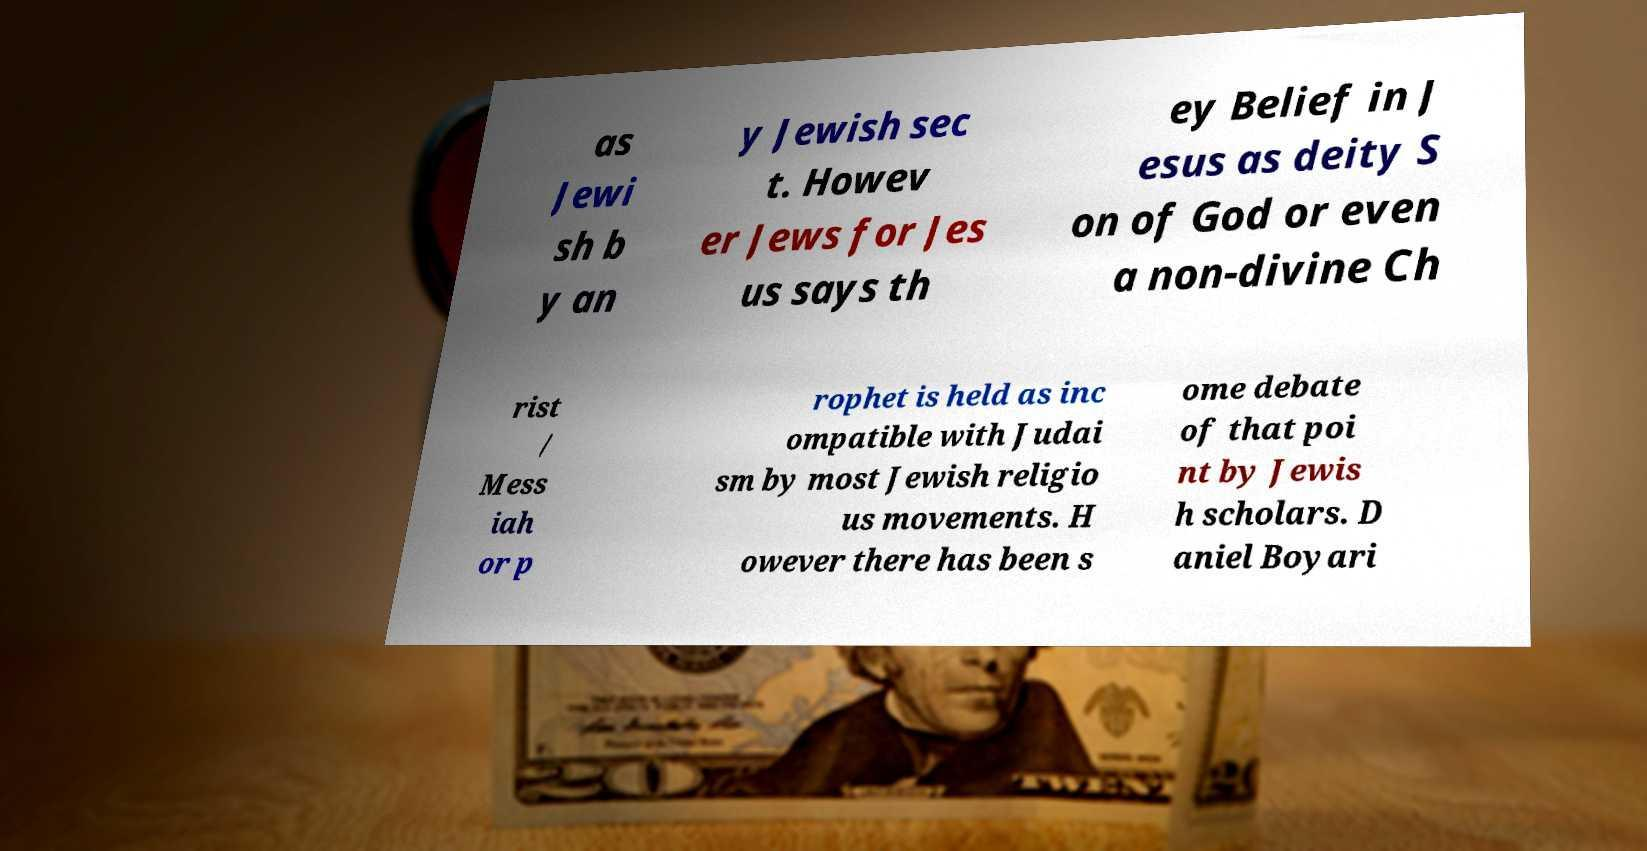Please read and relay the text visible in this image. What does it say? as Jewi sh b y an y Jewish sec t. Howev er Jews for Jes us says th ey Belief in J esus as deity S on of God or even a non-divine Ch rist / Mess iah or p rophet is held as inc ompatible with Judai sm by most Jewish religio us movements. H owever there has been s ome debate of that poi nt by Jewis h scholars. D aniel Boyari 